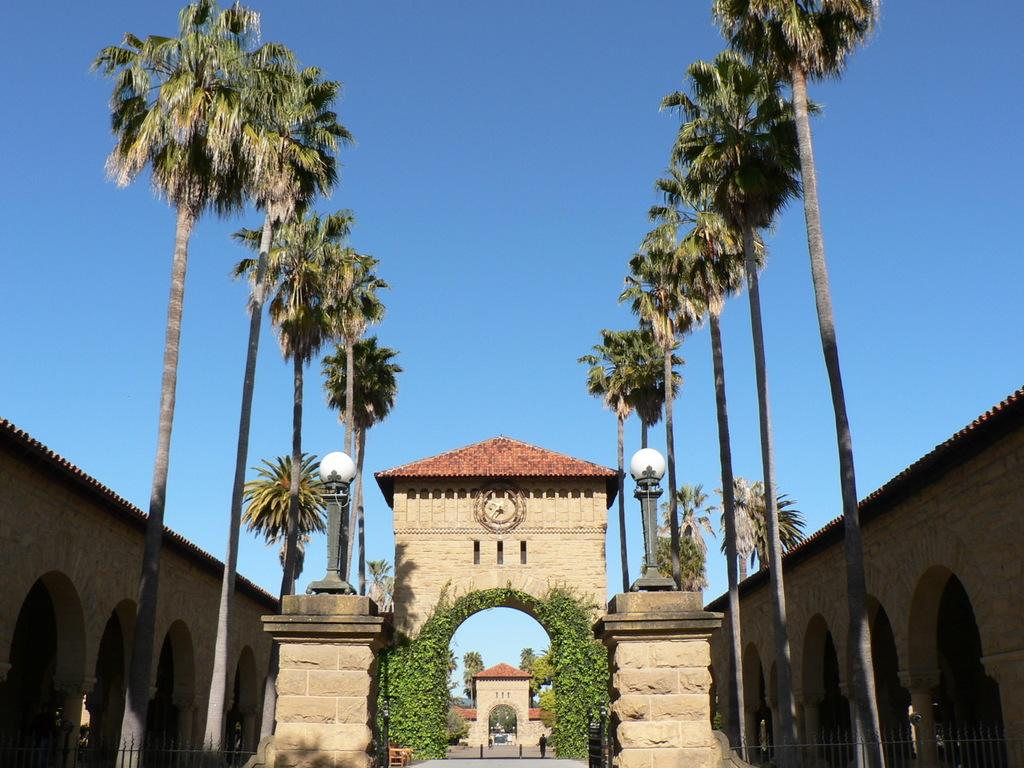What type of natural elements can be seen in the image? There are trees in the image. What architectural features are present in the image? There are arches, fences, poles, and a gate in the image. What man-made object is visible in the image? There is a table in the image. What is the person in the image doing? The person is on the ground in the image. What can be seen in the background of the image? The sky is visible in the background of the image. What type of ground is the person standing on in the image? The person is not standing in the image; they are on the ground. What type of tray is being used to serve the objects in the image? There is no tray present in the image. 